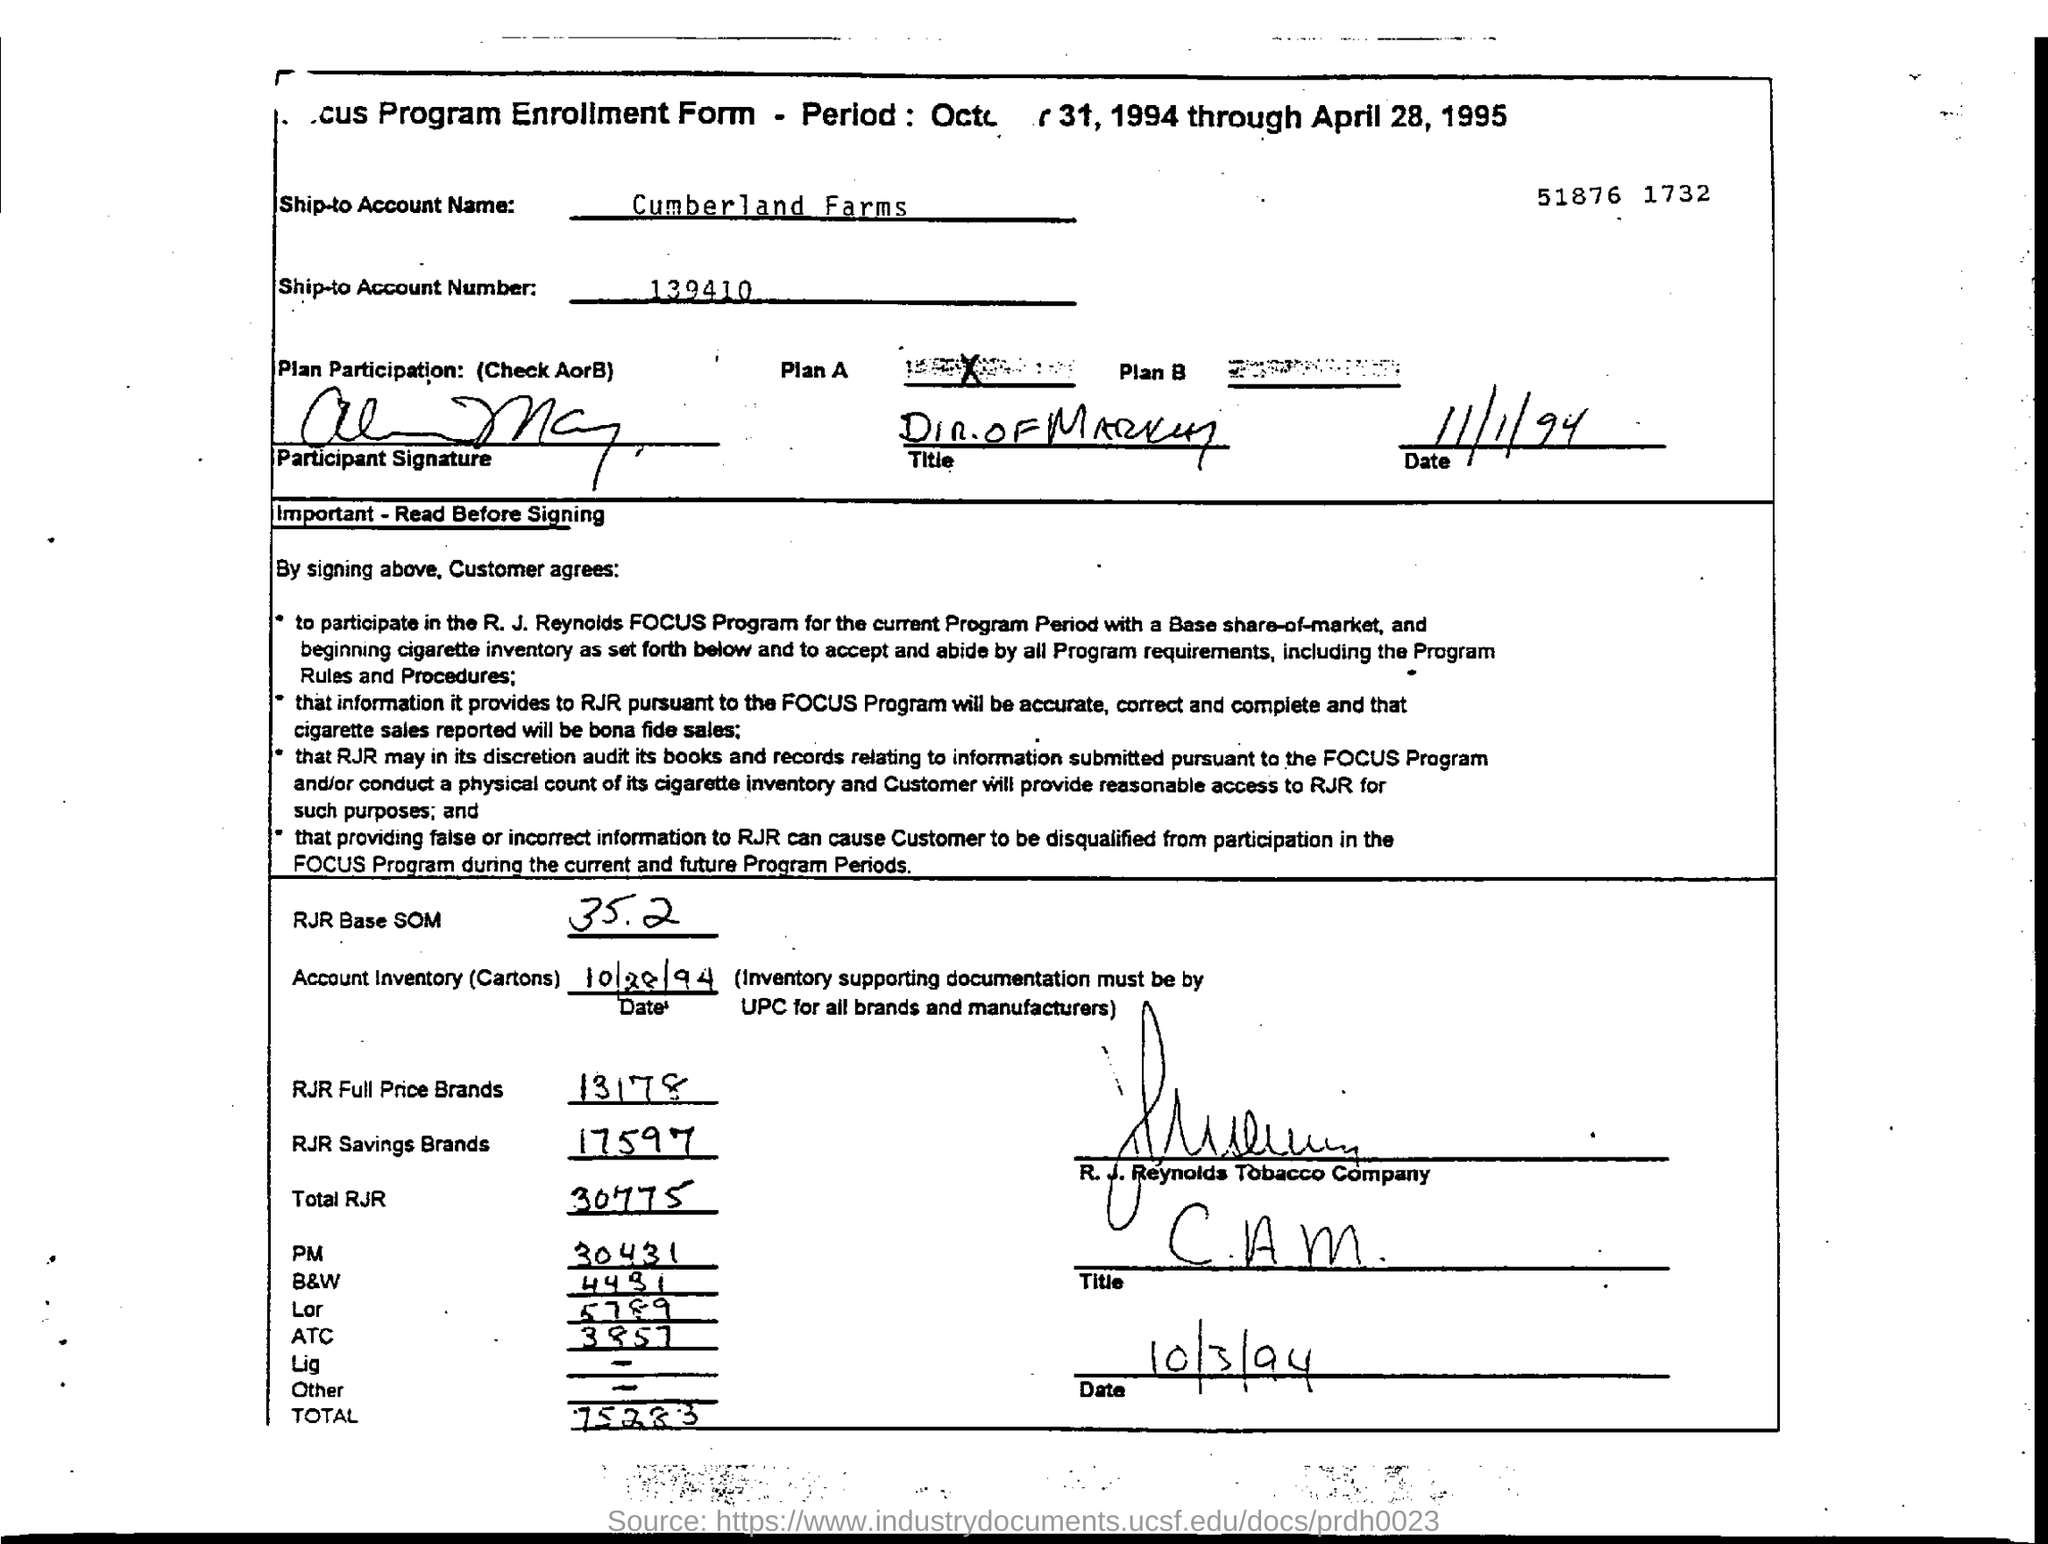List a handful of essential elements in this visual. What is the ship-to account number mentioned in the form? It is 139410.... The RJR Base SOM mentioned in the form is 35.2.." refers to the value 35.2 associated with the acronym "RJR Base SOM. The ship-to account name provided in the form is 'Cumberland Farms'. 